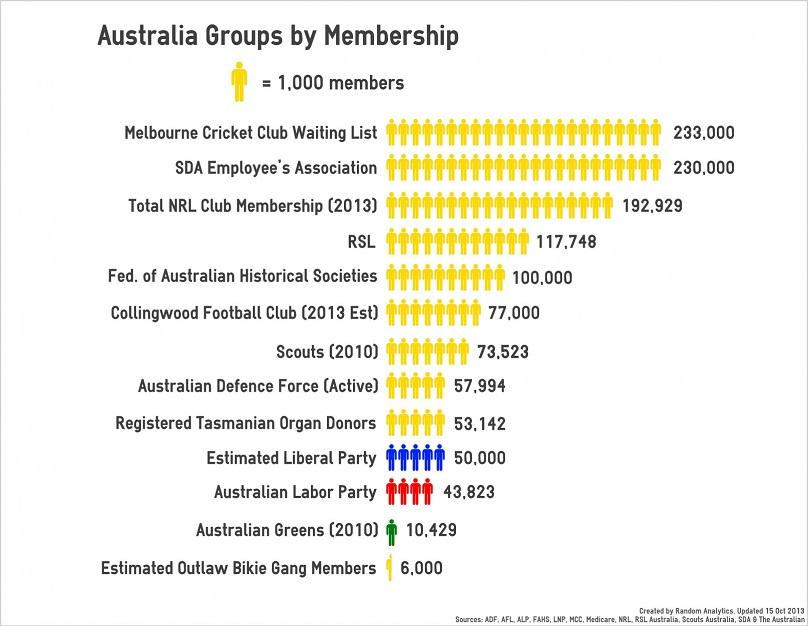List a handful of essential elements in this visual. The Australian Greens, which joined the Which Australia Group in 2010, has the second fewest number of members among all the organizations in the group. The combined membership of the Australian Labor Party and the Liberal Party is 93,823. Of the groups that have members with a count below fifty thousand, there are three. The SDA Employee's Association is a member of the Which Australia Group, which has the second largest number of members among all the groups. There are three groups that have members with a numerical value greater than one lakh fifty thousand. 